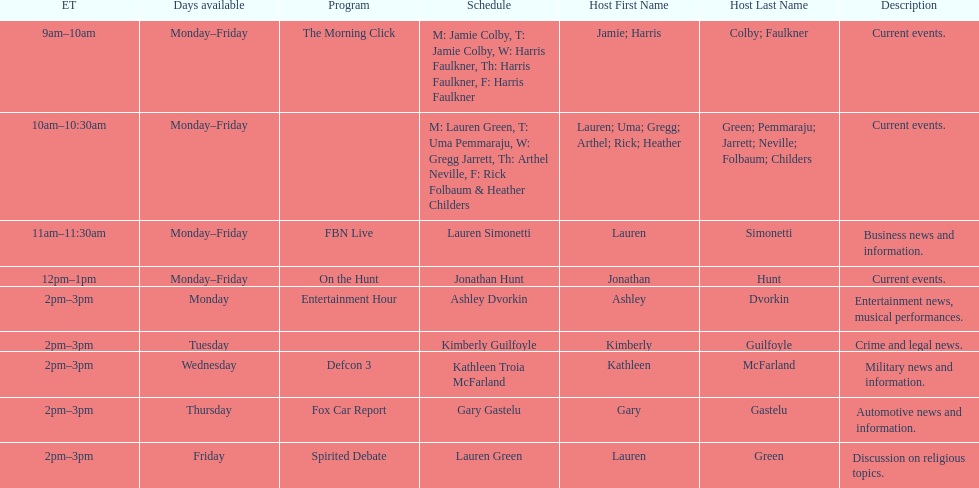Tell me the number of shows that only have one host per day. 7. 